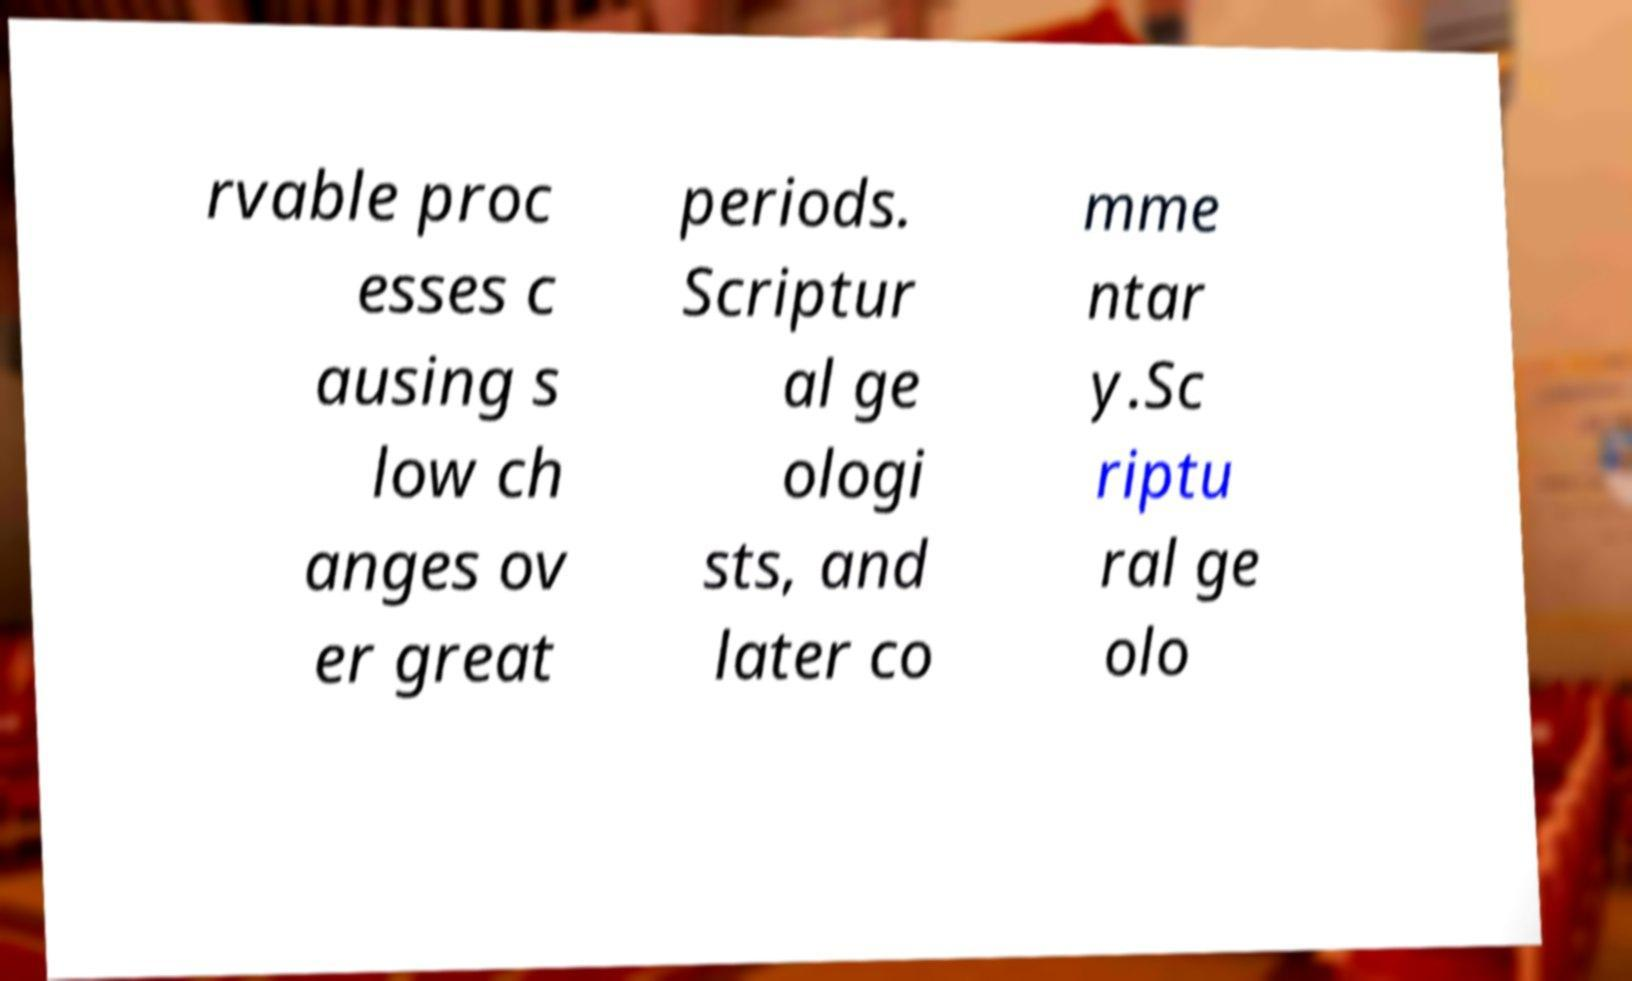Could you extract and type out the text from this image? rvable proc esses c ausing s low ch anges ov er great periods. Scriptur al ge ologi sts, and later co mme ntar y.Sc riptu ral ge olo 